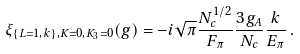<formula> <loc_0><loc_0><loc_500><loc_500>\xi _ { \{ L = 1 , k \} , K = 0 , K _ { 3 } = 0 } ( g ) = - i \sqrt { \pi } \frac { N _ { c } ^ { 1 / 2 } } { F _ { \pi } } \frac { 3 g _ { A } } { N _ { c } } \frac { k } { E _ { \pi } } \, .</formula> 